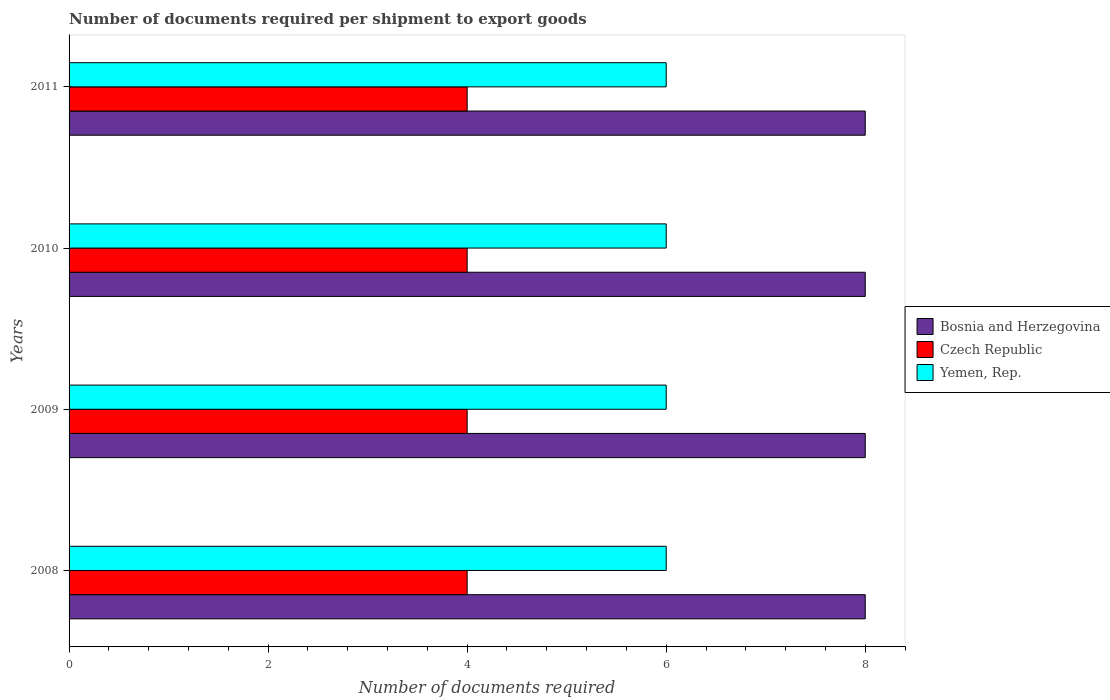How many groups of bars are there?
Your response must be concise. 4. Are the number of bars per tick equal to the number of legend labels?
Ensure brevity in your answer.  Yes. How many bars are there on the 1st tick from the bottom?
Give a very brief answer. 3. What is the number of documents required per shipment to export goods in Czech Republic in 2010?
Give a very brief answer. 4. Across all years, what is the maximum number of documents required per shipment to export goods in Bosnia and Herzegovina?
Offer a very short reply. 8. Across all years, what is the minimum number of documents required per shipment to export goods in Bosnia and Herzegovina?
Offer a terse response. 8. In which year was the number of documents required per shipment to export goods in Bosnia and Herzegovina minimum?
Offer a very short reply. 2008. What is the total number of documents required per shipment to export goods in Czech Republic in the graph?
Offer a very short reply. 16. What is the difference between the number of documents required per shipment to export goods in Yemen, Rep. in 2010 and that in 2011?
Your response must be concise. 0. What is the difference between the number of documents required per shipment to export goods in Yemen, Rep. in 2009 and the number of documents required per shipment to export goods in Czech Republic in 2008?
Ensure brevity in your answer.  2. In the year 2009, what is the difference between the number of documents required per shipment to export goods in Bosnia and Herzegovina and number of documents required per shipment to export goods in Yemen, Rep.?
Provide a short and direct response. 2. What is the ratio of the number of documents required per shipment to export goods in Czech Republic in 2008 to that in 2011?
Keep it short and to the point. 1. What is the difference between the highest and the second highest number of documents required per shipment to export goods in Bosnia and Herzegovina?
Ensure brevity in your answer.  0. What is the difference between the highest and the lowest number of documents required per shipment to export goods in Yemen, Rep.?
Offer a very short reply. 0. What does the 2nd bar from the top in 2008 represents?
Your response must be concise. Czech Republic. What does the 3rd bar from the bottom in 2011 represents?
Your response must be concise. Yemen, Rep. How many bars are there?
Provide a succinct answer. 12. Does the graph contain any zero values?
Your answer should be compact. No. Does the graph contain grids?
Provide a short and direct response. No. How are the legend labels stacked?
Ensure brevity in your answer.  Vertical. What is the title of the graph?
Offer a terse response. Number of documents required per shipment to export goods. Does "Monaco" appear as one of the legend labels in the graph?
Offer a very short reply. No. What is the label or title of the X-axis?
Your answer should be compact. Number of documents required. What is the Number of documents required in Bosnia and Herzegovina in 2009?
Give a very brief answer. 8. What is the Number of documents required of Czech Republic in 2009?
Your answer should be compact. 4. What is the Number of documents required of Yemen, Rep. in 2009?
Your response must be concise. 6. What is the Number of documents required of Yemen, Rep. in 2011?
Make the answer very short. 6. Across all years, what is the maximum Number of documents required of Bosnia and Herzegovina?
Provide a succinct answer. 8. Across all years, what is the maximum Number of documents required of Czech Republic?
Your answer should be compact. 4. Across all years, what is the minimum Number of documents required of Bosnia and Herzegovina?
Ensure brevity in your answer.  8. Across all years, what is the minimum Number of documents required of Czech Republic?
Offer a terse response. 4. Across all years, what is the minimum Number of documents required in Yemen, Rep.?
Your response must be concise. 6. What is the total Number of documents required of Bosnia and Herzegovina in the graph?
Your answer should be very brief. 32. What is the total Number of documents required in Yemen, Rep. in the graph?
Offer a very short reply. 24. What is the difference between the Number of documents required in Czech Republic in 2008 and that in 2009?
Your answer should be very brief. 0. What is the difference between the Number of documents required of Yemen, Rep. in 2008 and that in 2009?
Provide a short and direct response. 0. What is the difference between the Number of documents required in Bosnia and Herzegovina in 2008 and that in 2011?
Make the answer very short. 0. What is the difference between the Number of documents required in Czech Republic in 2008 and that in 2011?
Your answer should be very brief. 0. What is the difference between the Number of documents required in Czech Republic in 2009 and that in 2011?
Offer a very short reply. 0. What is the difference between the Number of documents required of Yemen, Rep. in 2009 and that in 2011?
Your answer should be very brief. 0. What is the difference between the Number of documents required of Yemen, Rep. in 2010 and that in 2011?
Give a very brief answer. 0. What is the difference between the Number of documents required in Bosnia and Herzegovina in 2008 and the Number of documents required in Yemen, Rep. in 2009?
Your answer should be very brief. 2. What is the difference between the Number of documents required in Czech Republic in 2008 and the Number of documents required in Yemen, Rep. in 2009?
Keep it short and to the point. -2. What is the difference between the Number of documents required in Bosnia and Herzegovina in 2008 and the Number of documents required in Yemen, Rep. in 2010?
Your answer should be compact. 2. What is the difference between the Number of documents required in Czech Republic in 2008 and the Number of documents required in Yemen, Rep. in 2010?
Offer a very short reply. -2. What is the difference between the Number of documents required in Bosnia and Herzegovina in 2008 and the Number of documents required in Yemen, Rep. in 2011?
Make the answer very short. 2. What is the difference between the Number of documents required in Czech Republic in 2008 and the Number of documents required in Yemen, Rep. in 2011?
Give a very brief answer. -2. What is the difference between the Number of documents required of Bosnia and Herzegovina in 2009 and the Number of documents required of Yemen, Rep. in 2010?
Provide a succinct answer. 2. What is the difference between the Number of documents required of Bosnia and Herzegovina in 2009 and the Number of documents required of Czech Republic in 2011?
Provide a short and direct response. 4. What is the difference between the Number of documents required in Czech Republic in 2009 and the Number of documents required in Yemen, Rep. in 2011?
Provide a succinct answer. -2. What is the difference between the Number of documents required of Bosnia and Herzegovina in 2010 and the Number of documents required of Yemen, Rep. in 2011?
Keep it short and to the point. 2. What is the difference between the Number of documents required of Czech Republic in 2010 and the Number of documents required of Yemen, Rep. in 2011?
Provide a succinct answer. -2. What is the average Number of documents required of Bosnia and Herzegovina per year?
Give a very brief answer. 8. What is the average Number of documents required in Yemen, Rep. per year?
Offer a very short reply. 6. In the year 2008, what is the difference between the Number of documents required of Czech Republic and Number of documents required of Yemen, Rep.?
Offer a very short reply. -2. In the year 2009, what is the difference between the Number of documents required in Bosnia and Herzegovina and Number of documents required in Czech Republic?
Keep it short and to the point. 4. In the year 2011, what is the difference between the Number of documents required of Bosnia and Herzegovina and Number of documents required of Yemen, Rep.?
Your answer should be compact. 2. In the year 2011, what is the difference between the Number of documents required of Czech Republic and Number of documents required of Yemen, Rep.?
Your answer should be very brief. -2. What is the ratio of the Number of documents required of Bosnia and Herzegovina in 2008 to that in 2009?
Offer a very short reply. 1. What is the ratio of the Number of documents required in Czech Republic in 2008 to that in 2009?
Your response must be concise. 1. What is the ratio of the Number of documents required of Yemen, Rep. in 2008 to that in 2009?
Your answer should be compact. 1. What is the ratio of the Number of documents required in Yemen, Rep. in 2008 to that in 2010?
Keep it short and to the point. 1. What is the ratio of the Number of documents required of Czech Republic in 2008 to that in 2011?
Your answer should be compact. 1. What is the ratio of the Number of documents required in Yemen, Rep. in 2008 to that in 2011?
Keep it short and to the point. 1. What is the ratio of the Number of documents required in Czech Republic in 2009 to that in 2010?
Keep it short and to the point. 1. What is the ratio of the Number of documents required of Yemen, Rep. in 2009 to that in 2010?
Make the answer very short. 1. What is the ratio of the Number of documents required of Bosnia and Herzegovina in 2009 to that in 2011?
Give a very brief answer. 1. What is the ratio of the Number of documents required in Czech Republic in 2009 to that in 2011?
Your answer should be very brief. 1. What is the ratio of the Number of documents required of Yemen, Rep. in 2009 to that in 2011?
Give a very brief answer. 1. What is the ratio of the Number of documents required of Bosnia and Herzegovina in 2010 to that in 2011?
Provide a short and direct response. 1. What is the ratio of the Number of documents required in Czech Republic in 2010 to that in 2011?
Offer a terse response. 1. What is the difference between the highest and the second highest Number of documents required in Bosnia and Herzegovina?
Keep it short and to the point. 0. What is the difference between the highest and the lowest Number of documents required of Bosnia and Herzegovina?
Keep it short and to the point. 0. What is the difference between the highest and the lowest Number of documents required in Yemen, Rep.?
Offer a terse response. 0. 